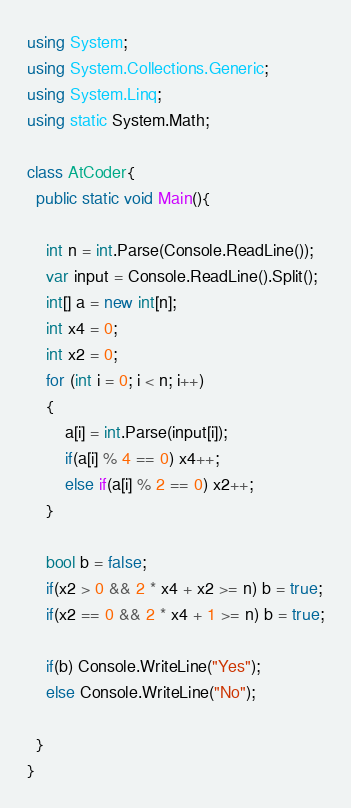Convert code to text. <code><loc_0><loc_0><loc_500><loc_500><_C#_>using System;
using System.Collections.Generic;
using System.Linq;
using static System.Math;

class AtCoder{
  public static void Main(){

    int n = int.Parse(Console.ReadLine());
    var input = Console.ReadLine().Split();
    int[] a = new int[n];
    int x4 = 0;
    int x2 = 0;
    for (int i = 0; i < n; i++)
    {
        a[i] = int.Parse(input[i]);
        if(a[i] % 4 == 0) x4++;
        else if(a[i] % 2 == 0) x2++;
    }

    bool b = false;
    if(x2 > 0 && 2 * x4 + x2 >= n) b = true;
    if(x2 == 0 && 2 * x4 + 1 >= n) b = true;

    if(b) Console.WriteLine("Yes");
    else Console.WriteLine("No");

  }
}</code> 